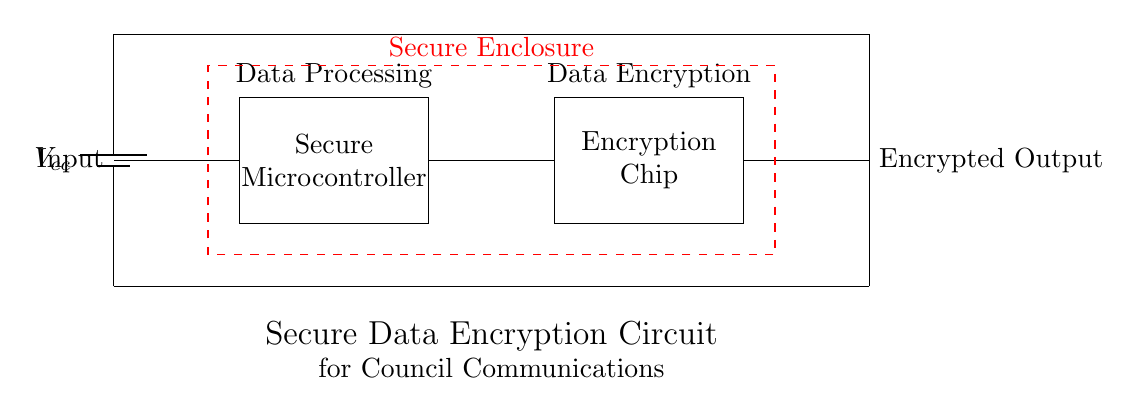What is the main power source used in this circuit? The power source depicted in the circuit is a battery, clearly labeled as Vcc. This indicates that it provides the necessary voltage to power the entire circuit.
Answer: Battery What component is responsible for data processing in the circuit? The processing of data is handled by the secure microcontroller, which is identified within the rectangular outline on the left side of the circuit.
Answer: Secure Microcontroller How many major components are in this circuit? Examining the circuit, there are three key components: the power source (battery), the secure microcontroller, and the encryption chip. Thus, the total count is three.
Answer: Three What is the type of output produced by the antenna? The antenna produces an encrypted output, as labeled on the right side of the circuit. This indicates that the output is a modified form of information that is secure.
Answer: Encrypted Output Which component comes directly after data processing in the circuit? Following the data processing done by the microcontroller, the encryption chip comes next, as indicated by the direct connection between these two components.
Answer: Encryption Chip What purpose does the dashed red rectangle serve in the circuit? The dashed red rectangle signifies a secure enclosure around the main components, indicating that these are protected for security and isolation purposes.
Answer: Secure Enclosure How does data flow through the circuit? Data initially enters through the input, flows to the secure microcontroller for processing, then passes to the encryption chip, and finally exits as encrypted output via the antenna.
Answer: Input to Encrypted Output 